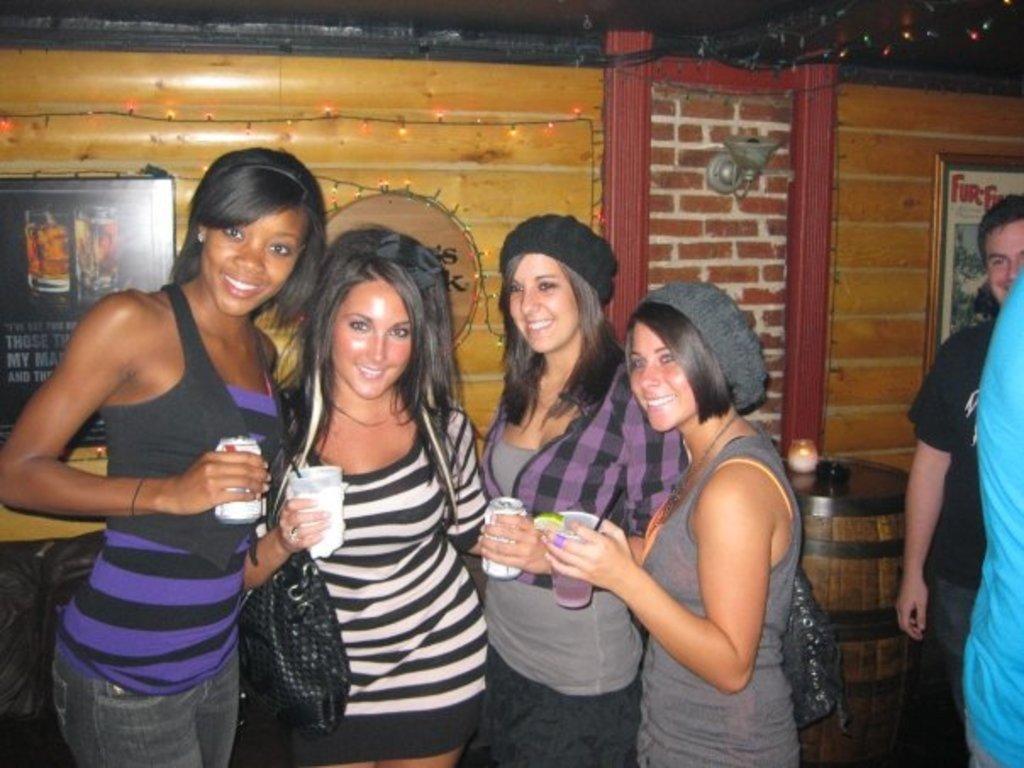Can you describe this image briefly? In the center of the image we can see four people are standing and they are smiling and they are holding glasses. On the right side of the image, we can see two persons are standing. In the background there is a wall, photo frames, string lights, one barrel and a few other objects. 